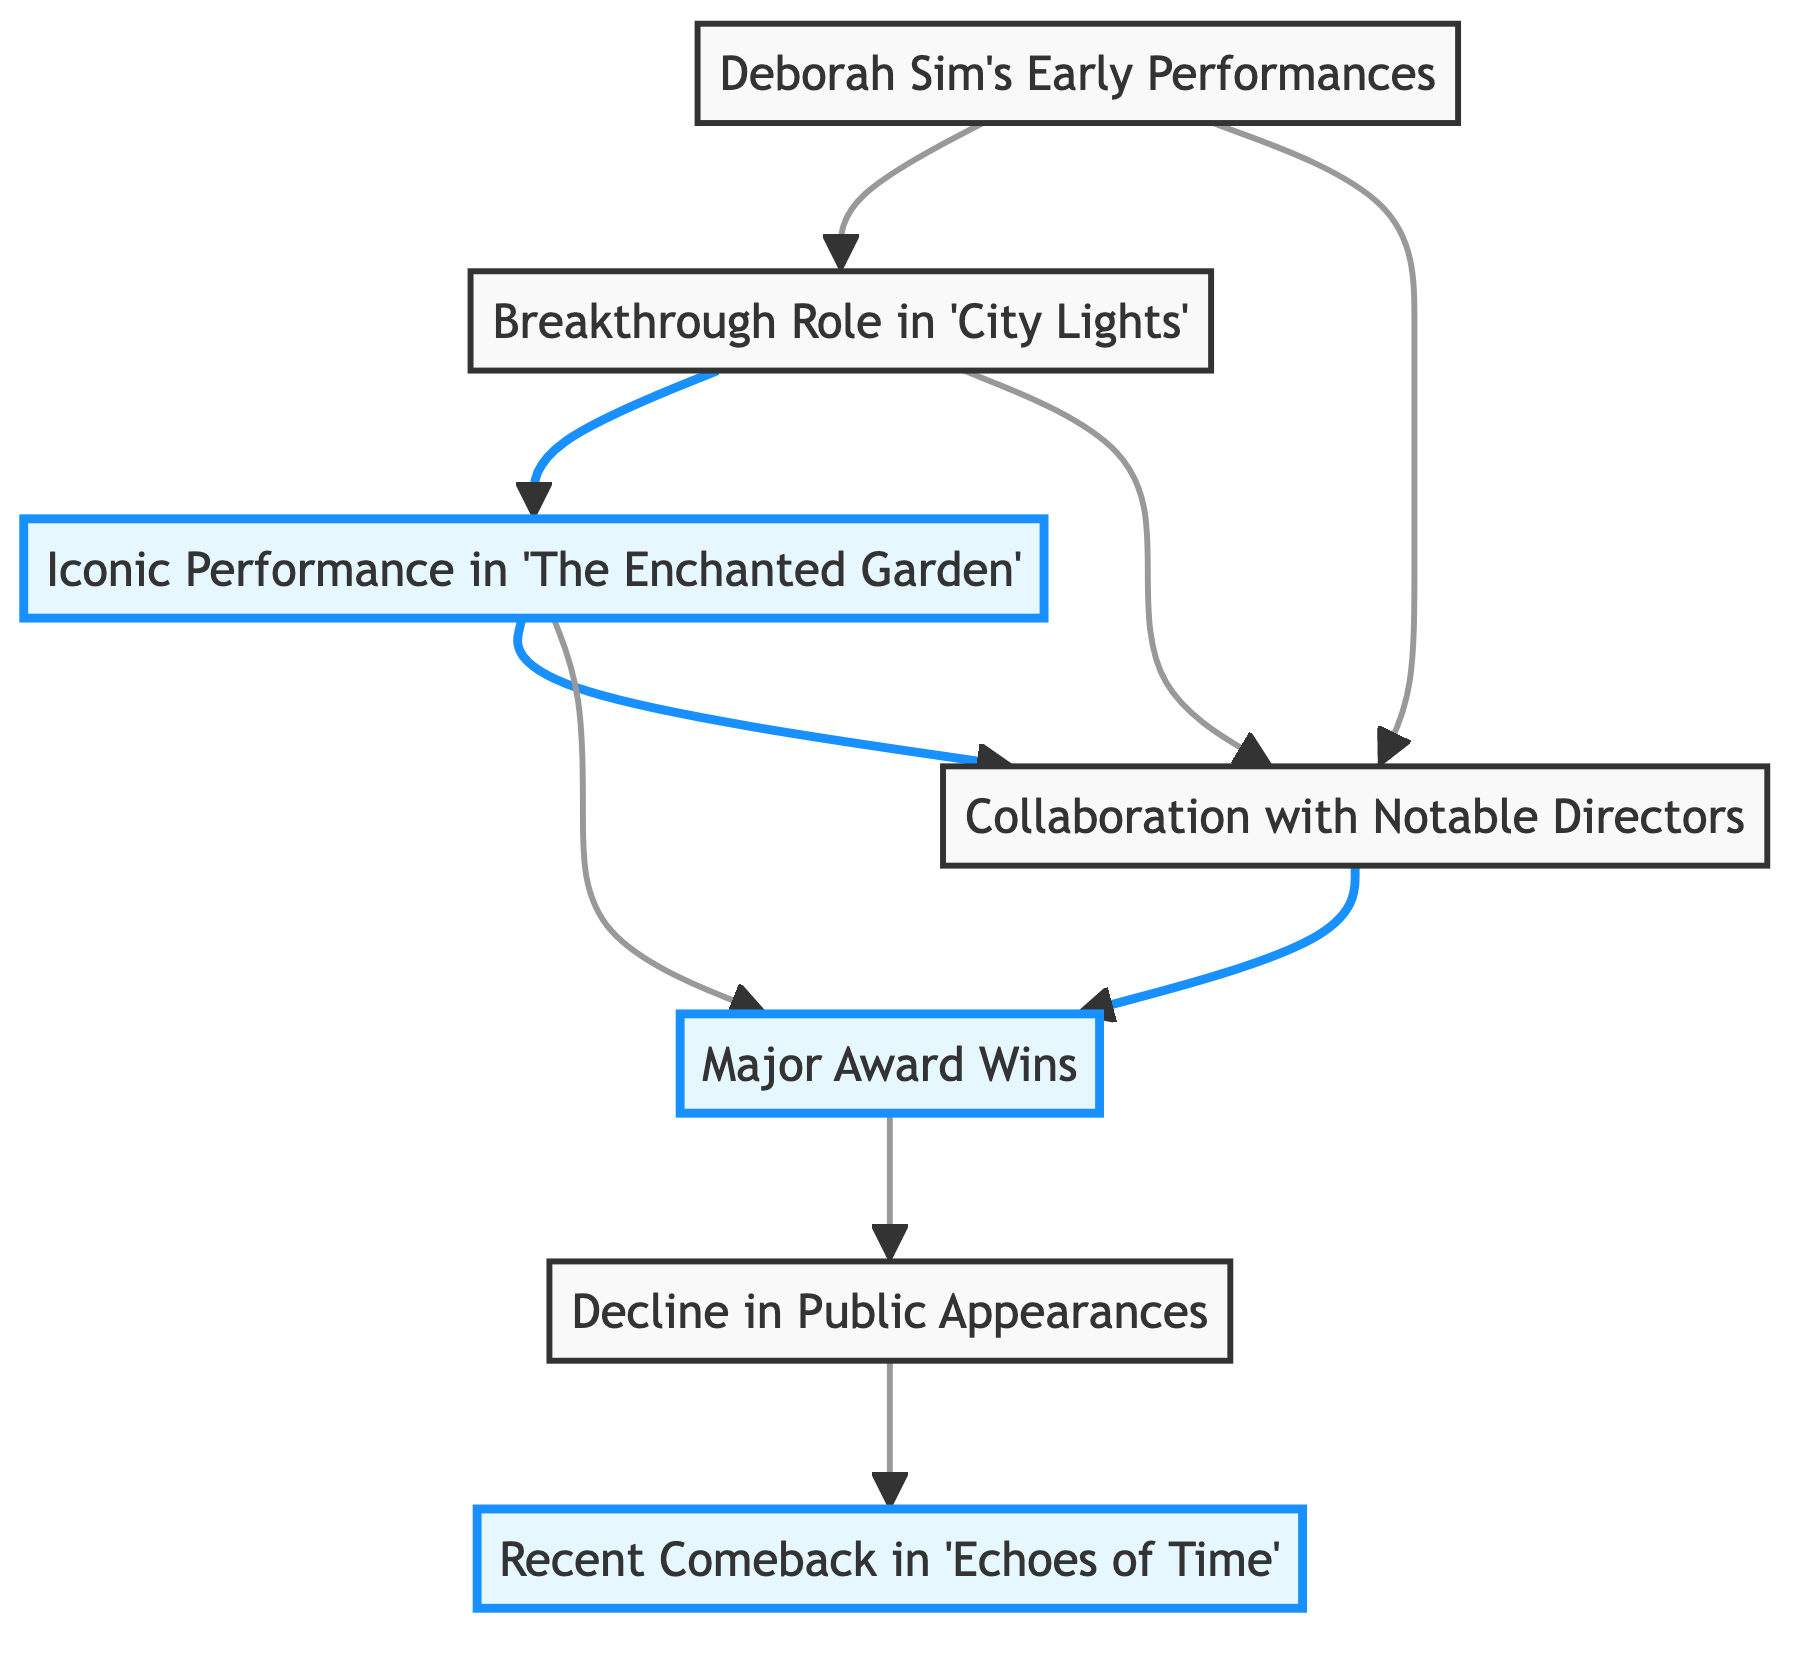What is the first node in the diagram? The first node in the diagram is "Deborah Sim's Early Performances," which is positioned at the top and serves as the foundation for the subsequent elements.
Answer: Deborah Sim's Early Performances How many major award wins are connected to the iconic performance? The iconic performance in "The Enchanted Garden" is directly connected to the "Major Award Wins" node, indicating it is one of the awards resulting from that performance. There's one direct connection from node 3 to node 5.
Answer: 1 Which performances contributed to the major award wins? "Iconic Performance in 'The Enchanted Garden'" and "Collaboration with Notable Directors" both lead to "Major Award Wins," making them the performances contributing to this recognition.
Answer: Iconic Performance in 'The Enchanted Garden' and Collaboration with Notable Directors What happens after the decline in public appearances? After the "Decline in Public Appearances" node, the flow leads to the "Recent Comeback in 'Echoes of Time'" node, indicating a revival of Deborah Sim's career following this decline.
Answer: Recent Comeback in 'Echoes of Time' Which directed or influenced the breakthrough role? The breakout role in "City Lights" was influenced by "Deborah Sim's Early Performances" and "Collaboration with Notable Directors," making these nodes the foundational influences for the breakthrough role.
Answer: Deborah Sim's Early Performances and Collaboration with Notable Directors How many nodes represent performances? The diagram has four distinct nodes representing performances: "Deborah Sim's Early Performances," "Breakthrough Role in 'City Lights,'" "Iconic Performance in 'The Enchanted Garden,'" and "Recent Comeback in 'Echoes of Time.'" Therefore, the total number of performance nodes is four.
Answer: 4 What is the relationship between breakthrough and iconic performances? The "Breakthrough Role in 'City Lights'" directly leads to the "Iconic Performance in 'The Enchanted Garden,'" indicating that the former was a precursor or stepping stone for the latter in her career trajectory.
Answer: Directly connected Which performance garnered major awards? The "Iconic Performance in 'The Enchanted Garden'" specifically led to "Major Award Wins," indicating that this performance was significant enough to achieve such recognition.
Answer: Iconic Performance in 'The Enchanted Garden' 